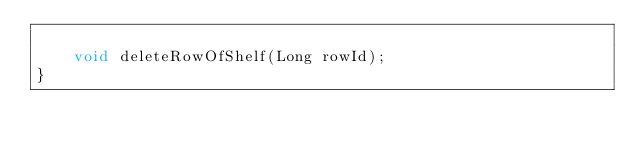Convert code to text. <code><loc_0><loc_0><loc_500><loc_500><_Java_>
    void deleteRowOfShelf(Long rowId);
}
</code> 